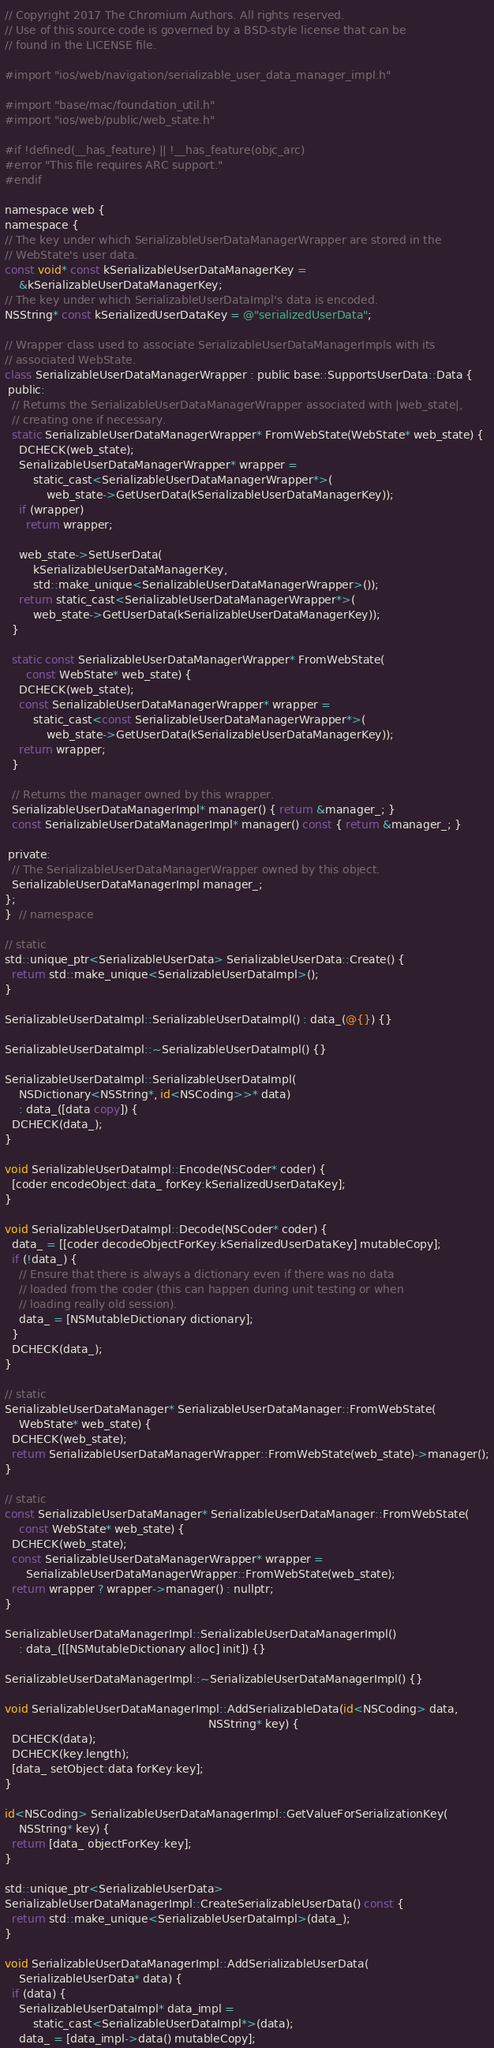<code> <loc_0><loc_0><loc_500><loc_500><_ObjectiveC_>// Copyright 2017 The Chromium Authors. All rights reserved.
// Use of this source code is governed by a BSD-style license that can be
// found in the LICENSE file.

#import "ios/web/navigation/serializable_user_data_manager_impl.h"

#import "base/mac/foundation_util.h"
#import "ios/web/public/web_state.h"

#if !defined(__has_feature) || !__has_feature(objc_arc)
#error "This file requires ARC support."
#endif

namespace web {
namespace {
// The key under which SerializableUserDataManagerWrapper are stored in the
// WebState's user data.
const void* const kSerializableUserDataManagerKey =
    &kSerializableUserDataManagerKey;
// The key under which SerializableUserDataImpl's data is encoded.
NSString* const kSerializedUserDataKey = @"serializedUserData";

// Wrapper class used to associate SerializableUserDataManagerImpls with its
// associated WebState.
class SerializableUserDataManagerWrapper : public base::SupportsUserData::Data {
 public:
  // Returns the SerializableUserDataManagerWrapper associated with |web_state|,
  // creating one if necessary.
  static SerializableUserDataManagerWrapper* FromWebState(WebState* web_state) {
    DCHECK(web_state);
    SerializableUserDataManagerWrapper* wrapper =
        static_cast<SerializableUserDataManagerWrapper*>(
            web_state->GetUserData(kSerializableUserDataManagerKey));
    if (wrapper)
      return wrapper;

    web_state->SetUserData(
        kSerializableUserDataManagerKey,
        std::make_unique<SerializableUserDataManagerWrapper>());
    return static_cast<SerializableUserDataManagerWrapper*>(
        web_state->GetUserData(kSerializableUserDataManagerKey));
  }

  static const SerializableUserDataManagerWrapper* FromWebState(
      const WebState* web_state) {
    DCHECK(web_state);
    const SerializableUserDataManagerWrapper* wrapper =
        static_cast<const SerializableUserDataManagerWrapper*>(
            web_state->GetUserData(kSerializableUserDataManagerKey));
    return wrapper;
  }

  // Returns the manager owned by this wrapper.
  SerializableUserDataManagerImpl* manager() { return &manager_; }
  const SerializableUserDataManagerImpl* manager() const { return &manager_; }

 private:
  // The SerializableUserDataManagerWrapper owned by this object.
  SerializableUserDataManagerImpl manager_;
};
}  // namespace

// static
std::unique_ptr<SerializableUserData> SerializableUserData::Create() {
  return std::make_unique<SerializableUserDataImpl>();
}

SerializableUserDataImpl::SerializableUserDataImpl() : data_(@{}) {}

SerializableUserDataImpl::~SerializableUserDataImpl() {}

SerializableUserDataImpl::SerializableUserDataImpl(
    NSDictionary<NSString*, id<NSCoding>>* data)
    : data_([data copy]) {
  DCHECK(data_);
}

void SerializableUserDataImpl::Encode(NSCoder* coder) {
  [coder encodeObject:data_ forKey:kSerializedUserDataKey];
}

void SerializableUserDataImpl::Decode(NSCoder* coder) {
  data_ = [[coder decodeObjectForKey:kSerializedUserDataKey] mutableCopy];
  if (!data_) {
    // Ensure that there is always a dictionary even if there was no data
    // loaded from the coder (this can happen during unit testing or when
    // loading really old session).
    data_ = [NSMutableDictionary dictionary];
  }
  DCHECK(data_);
}

// static
SerializableUserDataManager* SerializableUserDataManager::FromWebState(
    WebState* web_state) {
  DCHECK(web_state);
  return SerializableUserDataManagerWrapper::FromWebState(web_state)->manager();
}

// static
const SerializableUserDataManager* SerializableUserDataManager::FromWebState(
    const WebState* web_state) {
  DCHECK(web_state);
  const SerializableUserDataManagerWrapper* wrapper =
      SerializableUserDataManagerWrapper::FromWebState(web_state);
  return wrapper ? wrapper->manager() : nullptr;
}

SerializableUserDataManagerImpl::SerializableUserDataManagerImpl()
    : data_([[NSMutableDictionary alloc] init]) {}

SerializableUserDataManagerImpl::~SerializableUserDataManagerImpl() {}

void SerializableUserDataManagerImpl::AddSerializableData(id<NSCoding> data,
                                                          NSString* key) {
  DCHECK(data);
  DCHECK(key.length);
  [data_ setObject:data forKey:key];
}

id<NSCoding> SerializableUserDataManagerImpl::GetValueForSerializationKey(
    NSString* key) {
  return [data_ objectForKey:key];
}

std::unique_ptr<SerializableUserData>
SerializableUserDataManagerImpl::CreateSerializableUserData() const {
  return std::make_unique<SerializableUserDataImpl>(data_);
}

void SerializableUserDataManagerImpl::AddSerializableUserData(
    SerializableUserData* data) {
  if (data) {
    SerializableUserDataImpl* data_impl =
        static_cast<SerializableUserDataImpl*>(data);
    data_ = [data_impl->data() mutableCopy];</code> 